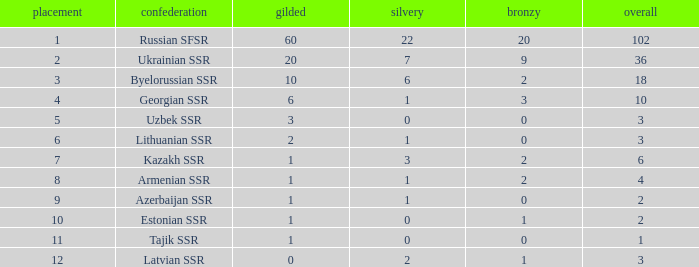What is the sum of bronzes for teams with more than 2 gold, ranked under 3, and less than 22 silver? 9.0. 